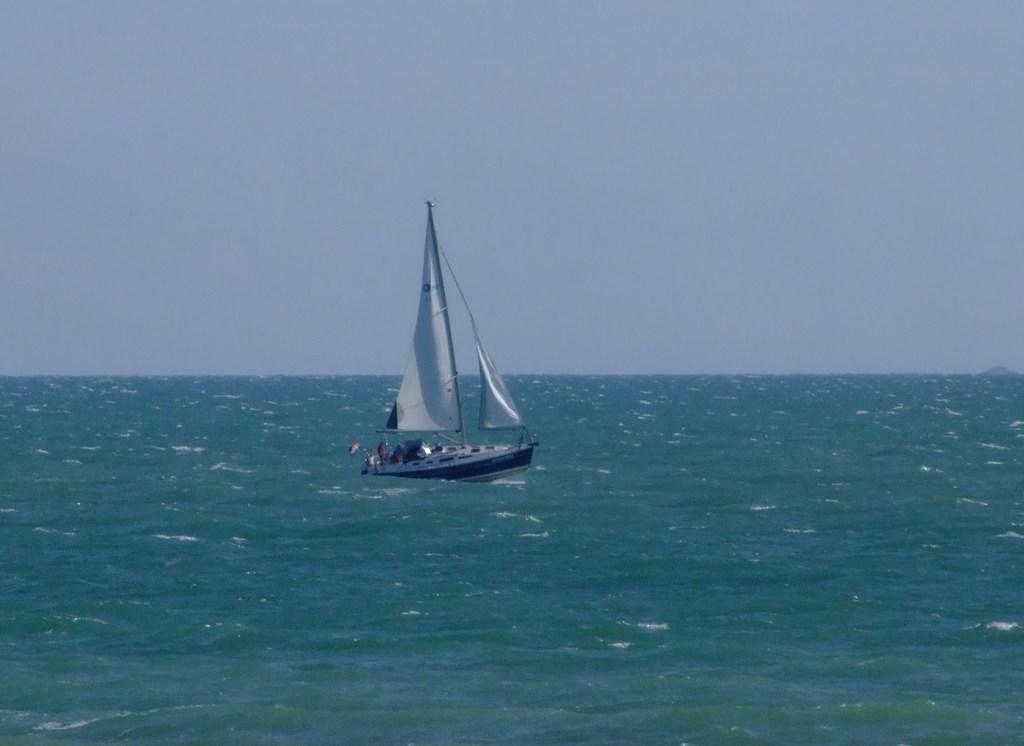Where was the image taken? The image is taken outdoors. What can be seen at the top of the image? The sky is visible at the top of the image. What is at the bottom of the image? There is a sea at the bottom of the image. What is the main subject in the middle of the image? There is a boat in the middle of the image. Where is the boat located in relation to the sea? The boat is on the sea. How many times does the mom fold the boat in the image? There is no mom present in the image, and the boat is not being folded. 